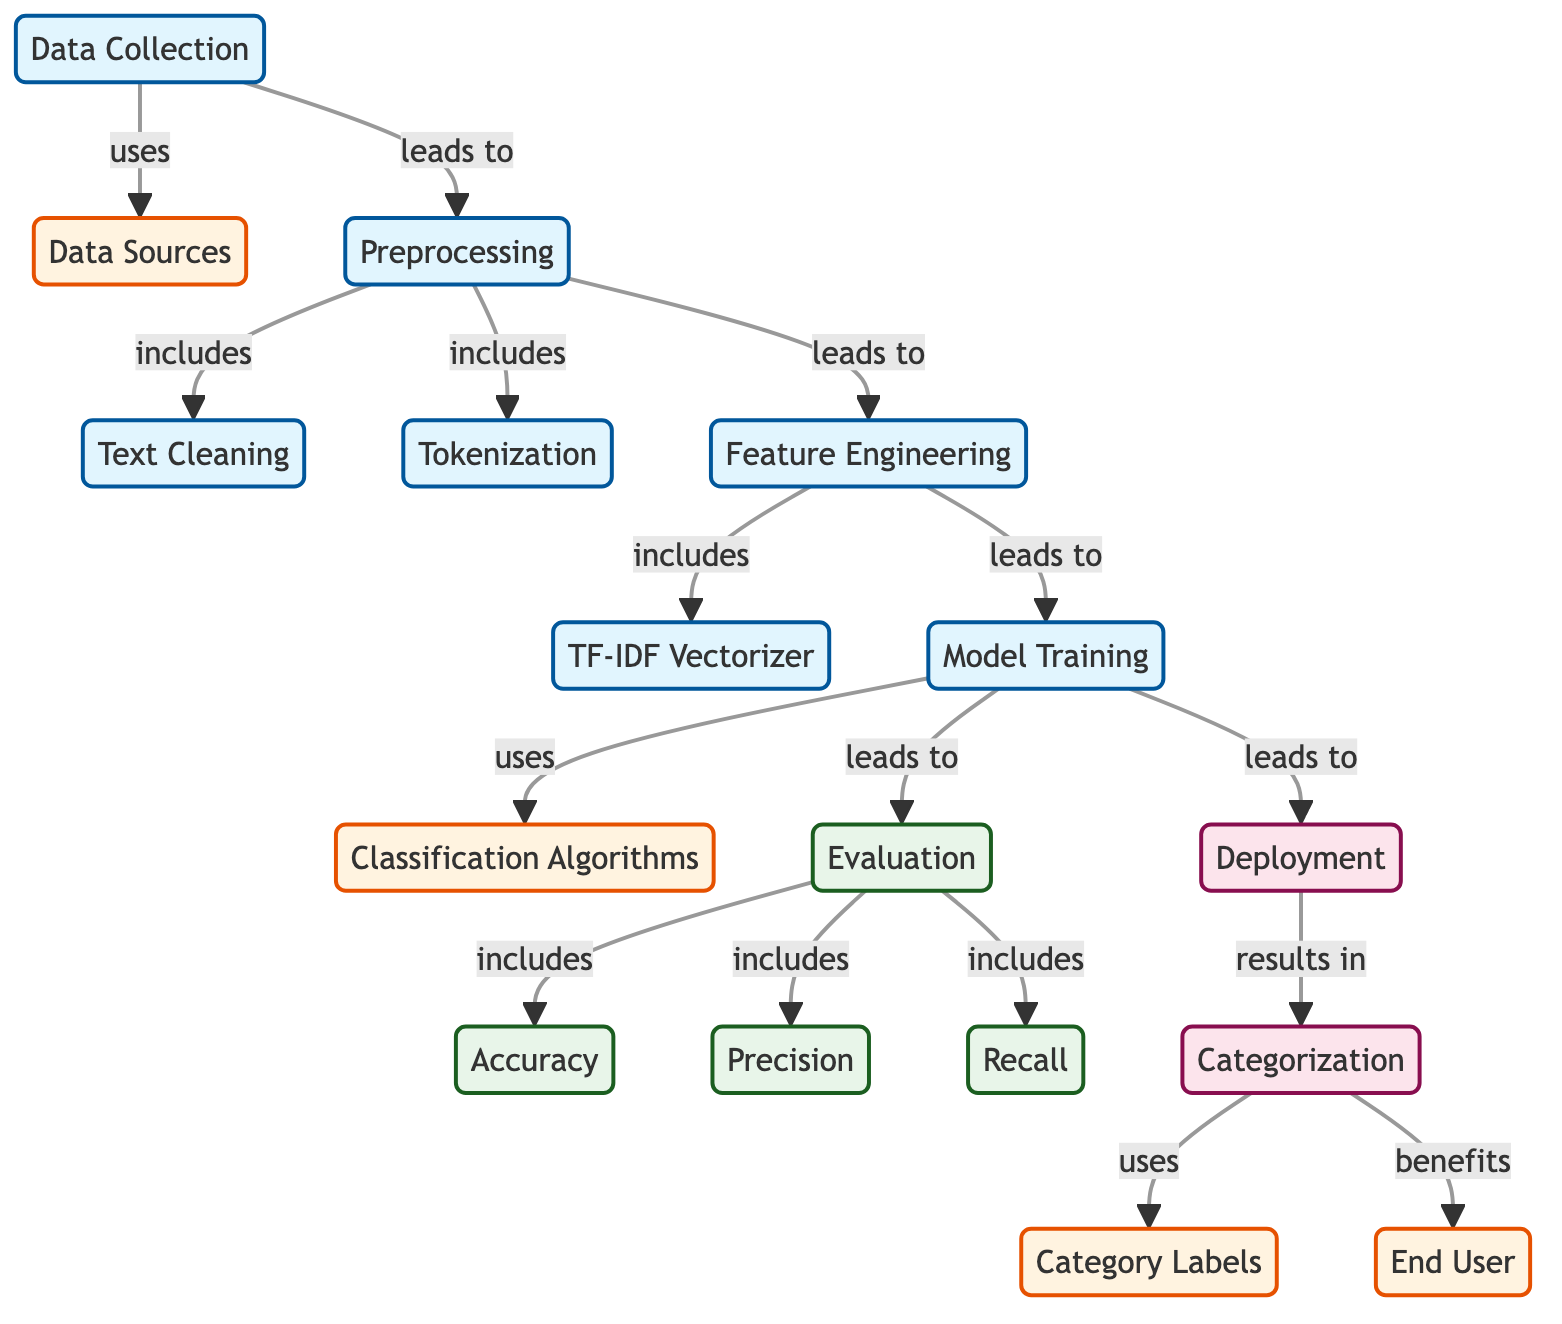What is the first node in the diagram? The first node in the diagram is "Data Collection." It initiates the process of Natural Language Processing for news article classification.
Answer: Data Collection How many evaluation metrics are shown in the diagram? The diagram shows three evaluation metrics: accuracy, precision, and recall. These metrics are important for assessing the performance of the classification model.
Answer: Three What follows preprocessing in the flow of the diagram? After preprocessing, the next step is feature engineering. This is where the cleaned and tokenized data is transformed into features for model training.
Answer: Feature Engineering Which node is categorized under deployment? The node categorized under deployment is "Categorization." This node represents the final step where articles are organized into specific categories for the end user.
Answer: Categorization What is the connection between model training and evaluation? Model training leads to evaluation, indicating that the model's performance is assessed after it is trained using the classification algorithms.
Answer: Evaluation Which process includes both text cleaning and tokenization? The preprocessing process includes both text cleaning and tokenization, meaning it involves multiple steps to prepare the data for subsequent feature engineering.
Answer: Preprocessing What are the data sources used for in the process? The data sources are used in the data collection process, providing the raw articles that need to be processed and classified.
Answer: Data Collection How does feature engineering use the TF-IDF vectorizer? In the feature engineering stage, the TF-IDF vectorizer is included as one method of converting text data into numerical features for training the model.
Answer: Feature Engineering Who benefits from the categorization process? The end user benefits from the categorization process as it organizes articles into relevant categories, optimizing their study time for current events.
Answer: End User 